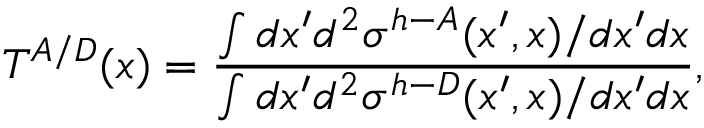<formula> <loc_0><loc_0><loc_500><loc_500>T ^ { A / D } ( x ) = \frac { \int d x ^ { \prime } d ^ { 2 } \sigma ^ { h - A } ( x ^ { \prime } , x ) / d x ^ { \prime } d x } { \int d x ^ { \prime } d ^ { 2 } \sigma ^ { h - D } ( x ^ { \prime } , x ) / d x ^ { \prime } d x } ,</formula> 